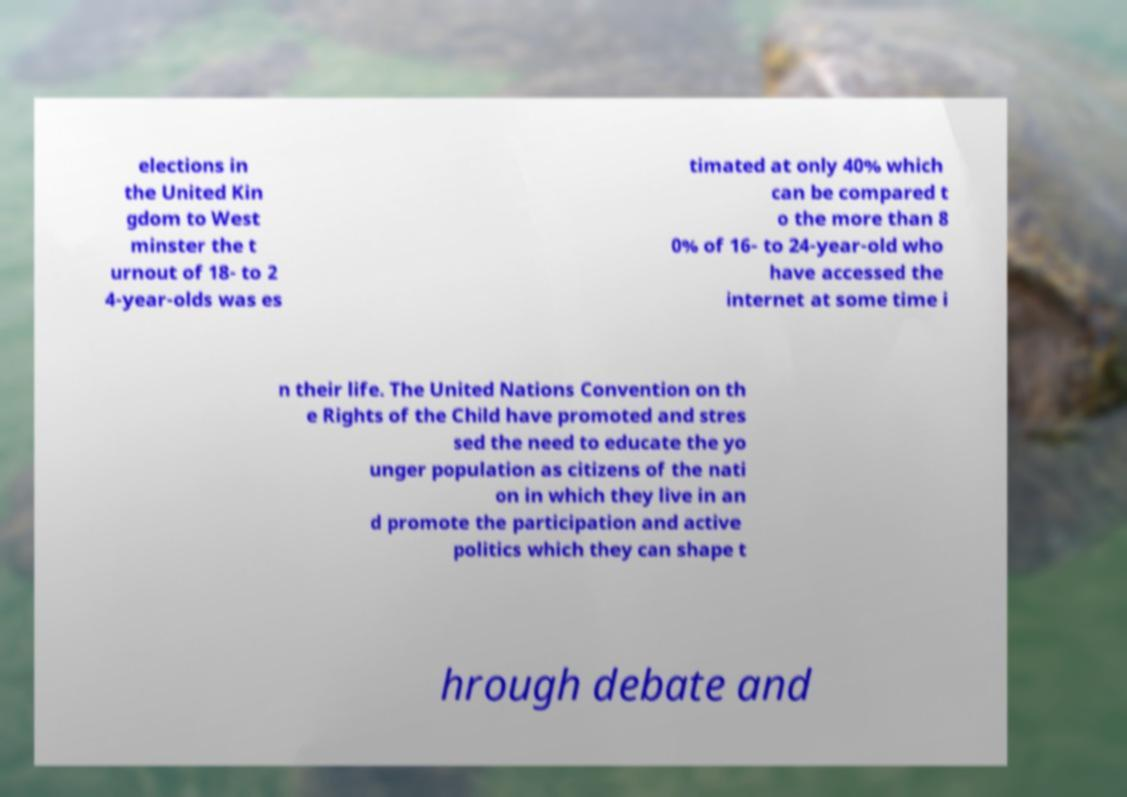Can you accurately transcribe the text from the provided image for me? elections in the United Kin gdom to West minster the t urnout of 18- to 2 4-year-olds was es timated at only 40% which can be compared t o the more than 8 0% of 16- to 24-year-old who have accessed the internet at some time i n their life. The United Nations Convention on th e Rights of the Child have promoted and stres sed the need to educate the yo unger population as citizens of the nati on in which they live in an d promote the participation and active politics which they can shape t hrough debate and 